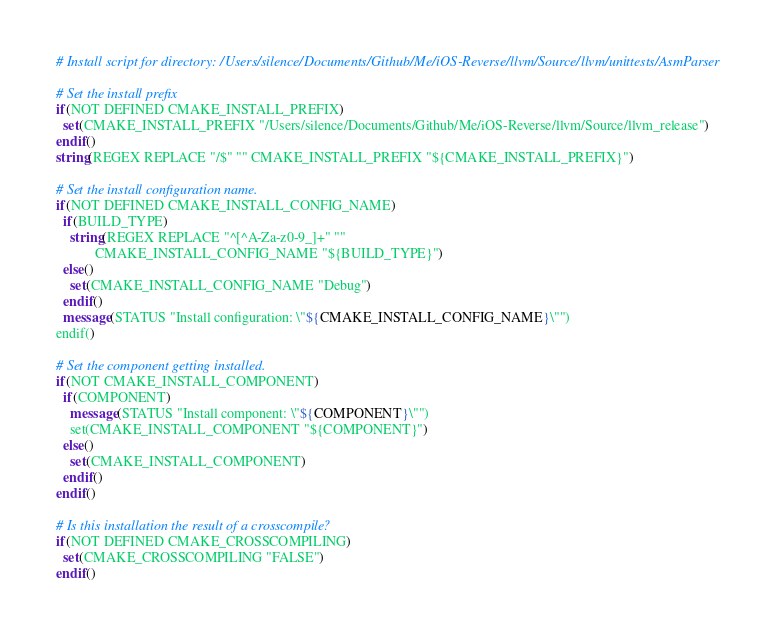<code> <loc_0><loc_0><loc_500><loc_500><_CMake_># Install script for directory: /Users/silence/Documents/Github/Me/iOS-Reverse/llvm/Source/llvm/unittests/AsmParser

# Set the install prefix
if(NOT DEFINED CMAKE_INSTALL_PREFIX)
  set(CMAKE_INSTALL_PREFIX "/Users/silence/Documents/Github/Me/iOS-Reverse/llvm/Source/llvm_release")
endif()
string(REGEX REPLACE "/$" "" CMAKE_INSTALL_PREFIX "${CMAKE_INSTALL_PREFIX}")

# Set the install configuration name.
if(NOT DEFINED CMAKE_INSTALL_CONFIG_NAME)
  if(BUILD_TYPE)
    string(REGEX REPLACE "^[^A-Za-z0-9_]+" ""
           CMAKE_INSTALL_CONFIG_NAME "${BUILD_TYPE}")
  else()
    set(CMAKE_INSTALL_CONFIG_NAME "Debug")
  endif()
  message(STATUS "Install configuration: \"${CMAKE_INSTALL_CONFIG_NAME}\"")
endif()

# Set the component getting installed.
if(NOT CMAKE_INSTALL_COMPONENT)
  if(COMPONENT)
    message(STATUS "Install component: \"${COMPONENT}\"")
    set(CMAKE_INSTALL_COMPONENT "${COMPONENT}")
  else()
    set(CMAKE_INSTALL_COMPONENT)
  endif()
endif()

# Is this installation the result of a crosscompile?
if(NOT DEFINED CMAKE_CROSSCOMPILING)
  set(CMAKE_CROSSCOMPILING "FALSE")
endif()

</code> 